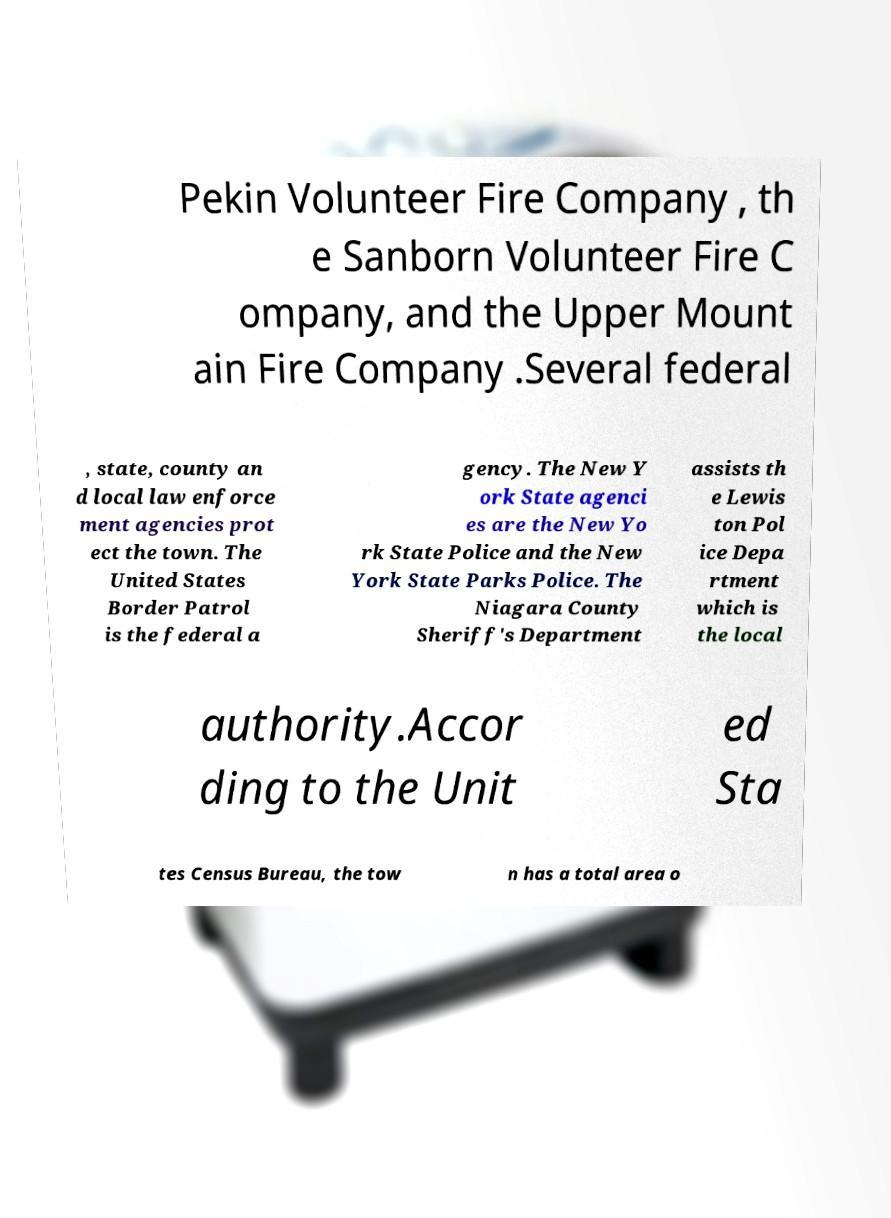I need the written content from this picture converted into text. Can you do that? Pekin Volunteer Fire Company , th e Sanborn Volunteer Fire C ompany, and the Upper Mount ain Fire Company .Several federal , state, county an d local law enforce ment agencies prot ect the town. The United States Border Patrol is the federal a gency. The New Y ork State agenci es are the New Yo rk State Police and the New York State Parks Police. The Niagara County Sheriff's Department assists th e Lewis ton Pol ice Depa rtment which is the local authority.Accor ding to the Unit ed Sta tes Census Bureau, the tow n has a total area o 